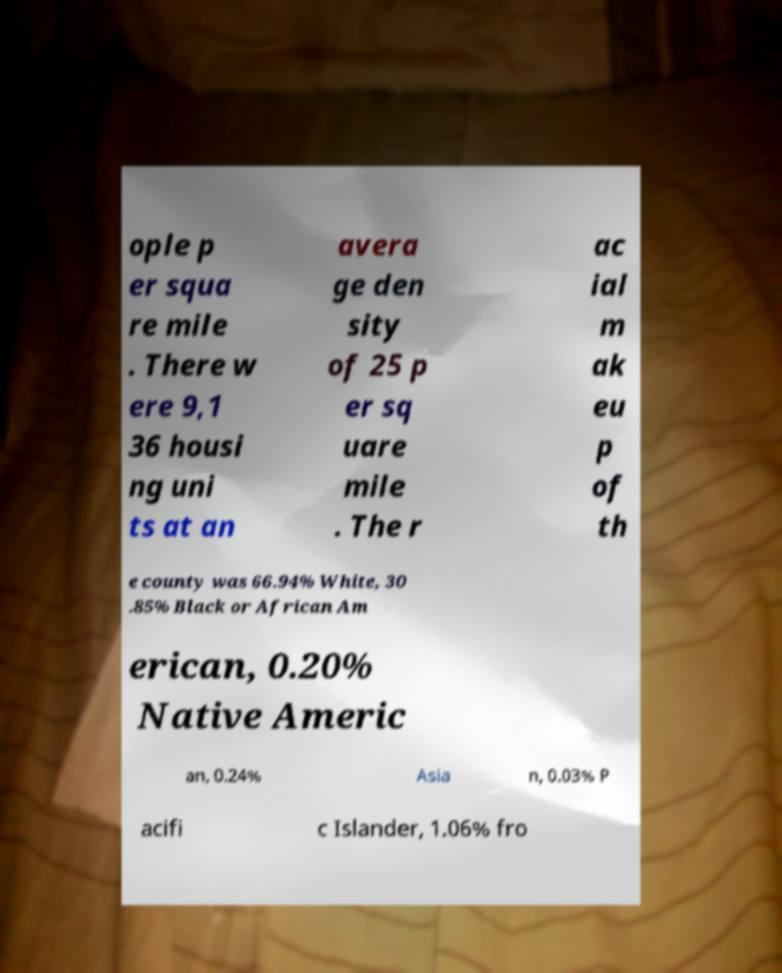For documentation purposes, I need the text within this image transcribed. Could you provide that? ople p er squa re mile . There w ere 9,1 36 housi ng uni ts at an avera ge den sity of 25 p er sq uare mile . The r ac ial m ak eu p of th e county was 66.94% White, 30 .85% Black or African Am erican, 0.20% Native Americ an, 0.24% Asia n, 0.03% P acifi c Islander, 1.06% fro 